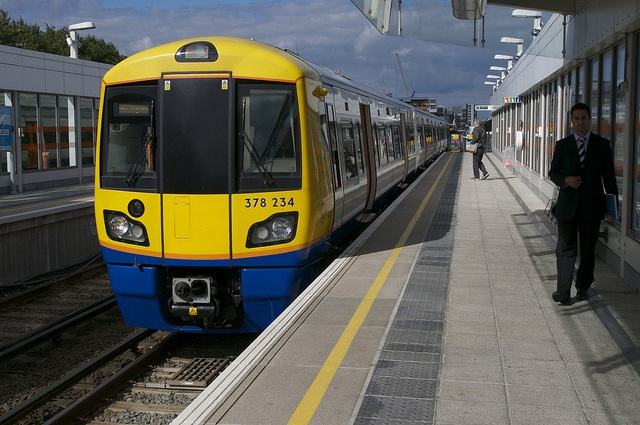Describe the objects in this image and their specific colors. I can see train in gray, black, gold, and navy tones, people in gray and black tones, people in gray, black, and darkgray tones, book in gray, black, and darkblue tones, and tie in gray and black tones in this image. 